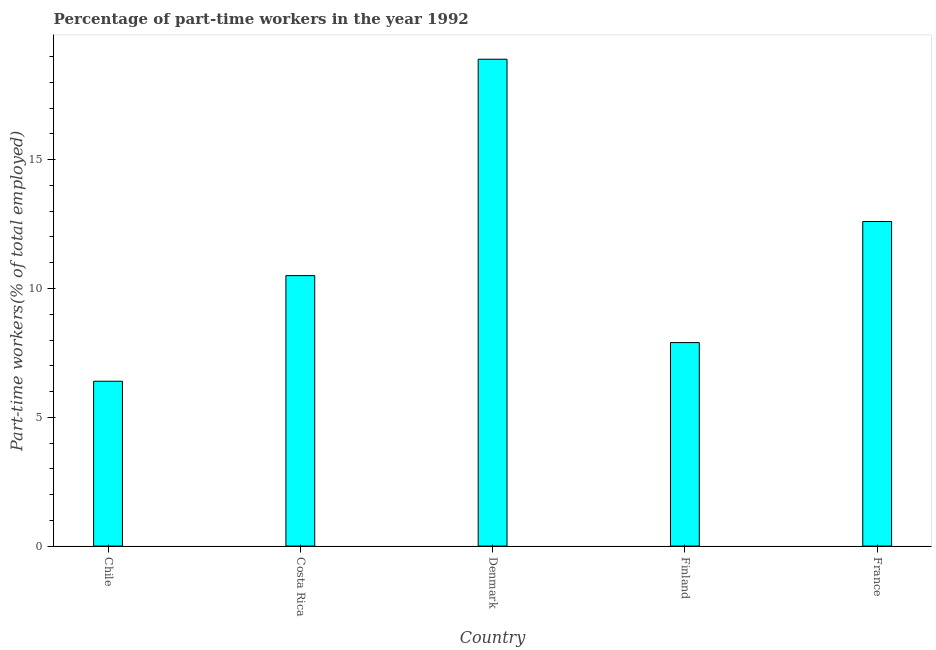Does the graph contain grids?
Make the answer very short. No. What is the title of the graph?
Ensure brevity in your answer.  Percentage of part-time workers in the year 1992. What is the label or title of the Y-axis?
Offer a terse response. Part-time workers(% of total employed). What is the percentage of part-time workers in France?
Keep it short and to the point. 12.6. Across all countries, what is the maximum percentage of part-time workers?
Your answer should be compact. 18.9. Across all countries, what is the minimum percentage of part-time workers?
Provide a short and direct response. 6.4. In which country was the percentage of part-time workers maximum?
Make the answer very short. Denmark. What is the sum of the percentage of part-time workers?
Give a very brief answer. 56.3. What is the difference between the percentage of part-time workers in Chile and Denmark?
Offer a very short reply. -12.5. What is the average percentage of part-time workers per country?
Provide a succinct answer. 11.26. What is the median percentage of part-time workers?
Offer a very short reply. 10.5. What is the ratio of the percentage of part-time workers in Finland to that in France?
Your answer should be compact. 0.63. What is the difference between the highest and the second highest percentage of part-time workers?
Give a very brief answer. 6.3. Is the sum of the percentage of part-time workers in Costa Rica and Denmark greater than the maximum percentage of part-time workers across all countries?
Your response must be concise. Yes. In how many countries, is the percentage of part-time workers greater than the average percentage of part-time workers taken over all countries?
Ensure brevity in your answer.  2. Are all the bars in the graph horizontal?
Offer a terse response. No. What is the Part-time workers(% of total employed) of Chile?
Keep it short and to the point. 6.4. What is the Part-time workers(% of total employed) of Costa Rica?
Ensure brevity in your answer.  10.5. What is the Part-time workers(% of total employed) in Denmark?
Your response must be concise. 18.9. What is the Part-time workers(% of total employed) of Finland?
Your answer should be very brief. 7.9. What is the Part-time workers(% of total employed) of France?
Make the answer very short. 12.6. What is the difference between the Part-time workers(% of total employed) in Chile and Costa Rica?
Your answer should be very brief. -4.1. What is the difference between the Part-time workers(% of total employed) in Chile and France?
Keep it short and to the point. -6.2. What is the difference between the Part-time workers(% of total employed) in Costa Rica and Finland?
Your answer should be compact. 2.6. What is the difference between the Part-time workers(% of total employed) in Denmark and Finland?
Your answer should be very brief. 11. What is the ratio of the Part-time workers(% of total employed) in Chile to that in Costa Rica?
Offer a very short reply. 0.61. What is the ratio of the Part-time workers(% of total employed) in Chile to that in Denmark?
Offer a terse response. 0.34. What is the ratio of the Part-time workers(% of total employed) in Chile to that in Finland?
Your answer should be compact. 0.81. What is the ratio of the Part-time workers(% of total employed) in Chile to that in France?
Your response must be concise. 0.51. What is the ratio of the Part-time workers(% of total employed) in Costa Rica to that in Denmark?
Ensure brevity in your answer.  0.56. What is the ratio of the Part-time workers(% of total employed) in Costa Rica to that in Finland?
Your answer should be very brief. 1.33. What is the ratio of the Part-time workers(% of total employed) in Costa Rica to that in France?
Offer a terse response. 0.83. What is the ratio of the Part-time workers(% of total employed) in Denmark to that in Finland?
Give a very brief answer. 2.39. What is the ratio of the Part-time workers(% of total employed) in Finland to that in France?
Offer a terse response. 0.63. 